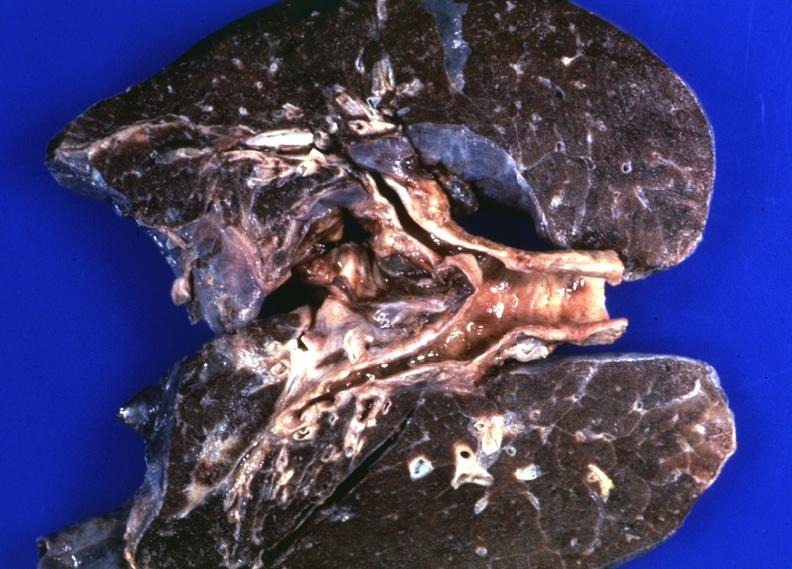what does this image show?
Answer the question using a single word or phrase. Lungs 